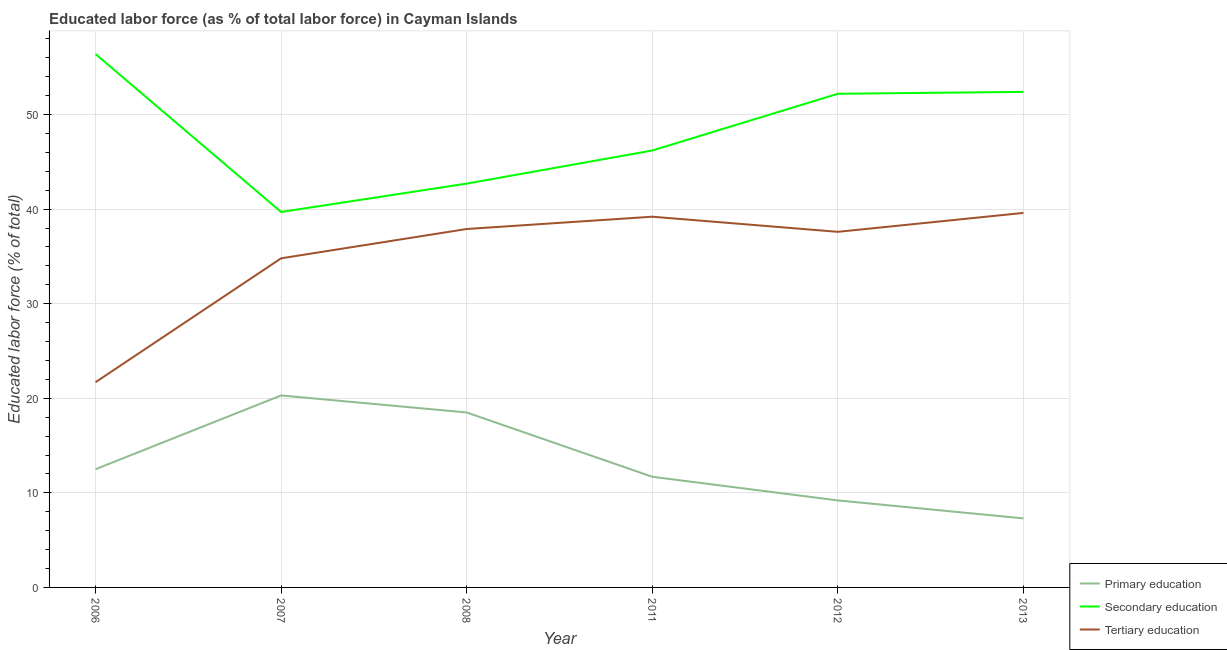Is the number of lines equal to the number of legend labels?
Keep it short and to the point. Yes. What is the percentage of labor force who received primary education in 2006?
Ensure brevity in your answer.  12.5. Across all years, what is the maximum percentage of labor force who received tertiary education?
Offer a very short reply. 39.6. Across all years, what is the minimum percentage of labor force who received tertiary education?
Your answer should be compact. 21.7. In which year was the percentage of labor force who received primary education minimum?
Your response must be concise. 2013. What is the total percentage of labor force who received secondary education in the graph?
Your answer should be very brief. 289.6. What is the difference between the percentage of labor force who received secondary education in 2011 and that in 2013?
Your answer should be compact. -6.2. What is the difference between the percentage of labor force who received tertiary education in 2013 and the percentage of labor force who received secondary education in 2012?
Give a very brief answer. -12.6. What is the average percentage of labor force who received primary education per year?
Offer a very short reply. 13.25. In the year 2012, what is the difference between the percentage of labor force who received tertiary education and percentage of labor force who received secondary education?
Ensure brevity in your answer.  -14.6. In how many years, is the percentage of labor force who received secondary education greater than 10 %?
Give a very brief answer. 6. What is the ratio of the percentage of labor force who received primary education in 2008 to that in 2011?
Make the answer very short. 1.58. Is the difference between the percentage of labor force who received secondary education in 2006 and 2008 greater than the difference between the percentage of labor force who received primary education in 2006 and 2008?
Your answer should be very brief. Yes. What is the difference between the highest and the second highest percentage of labor force who received tertiary education?
Offer a terse response. 0.4. What is the difference between the highest and the lowest percentage of labor force who received tertiary education?
Give a very brief answer. 17.9. In how many years, is the percentage of labor force who received primary education greater than the average percentage of labor force who received primary education taken over all years?
Provide a short and direct response. 2. Is the sum of the percentage of labor force who received primary education in 2011 and 2012 greater than the maximum percentage of labor force who received tertiary education across all years?
Give a very brief answer. No. Does the percentage of labor force who received secondary education monotonically increase over the years?
Give a very brief answer. No. Is the percentage of labor force who received secondary education strictly greater than the percentage of labor force who received primary education over the years?
Provide a succinct answer. Yes. Is the percentage of labor force who received secondary education strictly less than the percentage of labor force who received primary education over the years?
Your answer should be compact. No. How many lines are there?
Make the answer very short. 3. How many years are there in the graph?
Provide a short and direct response. 6. Does the graph contain any zero values?
Provide a short and direct response. No. How many legend labels are there?
Your answer should be very brief. 3. How are the legend labels stacked?
Your answer should be very brief. Vertical. What is the title of the graph?
Ensure brevity in your answer.  Educated labor force (as % of total labor force) in Cayman Islands. What is the label or title of the Y-axis?
Offer a very short reply. Educated labor force (% of total). What is the Educated labor force (% of total) of Secondary education in 2006?
Ensure brevity in your answer.  56.4. What is the Educated labor force (% of total) in Tertiary education in 2006?
Offer a very short reply. 21.7. What is the Educated labor force (% of total) in Primary education in 2007?
Provide a succinct answer. 20.3. What is the Educated labor force (% of total) of Secondary education in 2007?
Your answer should be very brief. 39.7. What is the Educated labor force (% of total) of Tertiary education in 2007?
Ensure brevity in your answer.  34.8. What is the Educated labor force (% of total) of Secondary education in 2008?
Ensure brevity in your answer.  42.7. What is the Educated labor force (% of total) in Tertiary education in 2008?
Give a very brief answer. 37.9. What is the Educated labor force (% of total) in Primary education in 2011?
Make the answer very short. 11.7. What is the Educated labor force (% of total) in Secondary education in 2011?
Offer a very short reply. 46.2. What is the Educated labor force (% of total) in Tertiary education in 2011?
Ensure brevity in your answer.  39.2. What is the Educated labor force (% of total) in Primary education in 2012?
Provide a short and direct response. 9.2. What is the Educated labor force (% of total) in Secondary education in 2012?
Provide a short and direct response. 52.2. What is the Educated labor force (% of total) in Tertiary education in 2012?
Provide a short and direct response. 37.6. What is the Educated labor force (% of total) of Primary education in 2013?
Offer a terse response. 7.3. What is the Educated labor force (% of total) of Secondary education in 2013?
Provide a succinct answer. 52.4. What is the Educated labor force (% of total) of Tertiary education in 2013?
Your answer should be very brief. 39.6. Across all years, what is the maximum Educated labor force (% of total) in Primary education?
Ensure brevity in your answer.  20.3. Across all years, what is the maximum Educated labor force (% of total) of Secondary education?
Ensure brevity in your answer.  56.4. Across all years, what is the maximum Educated labor force (% of total) of Tertiary education?
Provide a short and direct response. 39.6. Across all years, what is the minimum Educated labor force (% of total) in Primary education?
Keep it short and to the point. 7.3. Across all years, what is the minimum Educated labor force (% of total) of Secondary education?
Ensure brevity in your answer.  39.7. Across all years, what is the minimum Educated labor force (% of total) in Tertiary education?
Provide a short and direct response. 21.7. What is the total Educated labor force (% of total) of Primary education in the graph?
Keep it short and to the point. 79.5. What is the total Educated labor force (% of total) in Secondary education in the graph?
Keep it short and to the point. 289.6. What is the total Educated labor force (% of total) of Tertiary education in the graph?
Your answer should be very brief. 210.8. What is the difference between the Educated labor force (% of total) of Tertiary education in 2006 and that in 2008?
Your answer should be very brief. -16.2. What is the difference between the Educated labor force (% of total) in Primary education in 2006 and that in 2011?
Your answer should be very brief. 0.8. What is the difference between the Educated labor force (% of total) in Secondary education in 2006 and that in 2011?
Your answer should be compact. 10.2. What is the difference between the Educated labor force (% of total) in Tertiary education in 2006 and that in 2011?
Ensure brevity in your answer.  -17.5. What is the difference between the Educated labor force (% of total) in Tertiary education in 2006 and that in 2012?
Provide a short and direct response. -15.9. What is the difference between the Educated labor force (% of total) of Tertiary education in 2006 and that in 2013?
Offer a terse response. -17.9. What is the difference between the Educated labor force (% of total) of Primary education in 2007 and that in 2008?
Offer a terse response. 1.8. What is the difference between the Educated labor force (% of total) of Primary education in 2007 and that in 2011?
Keep it short and to the point. 8.6. What is the difference between the Educated labor force (% of total) of Primary education in 2007 and that in 2013?
Ensure brevity in your answer.  13. What is the difference between the Educated labor force (% of total) of Tertiary education in 2007 and that in 2013?
Offer a very short reply. -4.8. What is the difference between the Educated labor force (% of total) in Secondary education in 2008 and that in 2011?
Make the answer very short. -3.5. What is the difference between the Educated labor force (% of total) in Primary education in 2008 and that in 2012?
Your response must be concise. 9.3. What is the difference between the Educated labor force (% of total) of Secondary education in 2008 and that in 2012?
Give a very brief answer. -9.5. What is the difference between the Educated labor force (% of total) in Tertiary education in 2008 and that in 2012?
Offer a terse response. 0.3. What is the difference between the Educated labor force (% of total) of Secondary education in 2008 and that in 2013?
Provide a succinct answer. -9.7. What is the difference between the Educated labor force (% of total) in Secondary education in 2011 and that in 2012?
Offer a very short reply. -6. What is the difference between the Educated labor force (% of total) in Tertiary education in 2011 and that in 2012?
Keep it short and to the point. 1.6. What is the difference between the Educated labor force (% of total) of Secondary education in 2011 and that in 2013?
Your answer should be compact. -6.2. What is the difference between the Educated labor force (% of total) in Primary education in 2006 and the Educated labor force (% of total) in Secondary education in 2007?
Offer a terse response. -27.2. What is the difference between the Educated labor force (% of total) in Primary education in 2006 and the Educated labor force (% of total) in Tertiary education in 2007?
Offer a terse response. -22.3. What is the difference between the Educated labor force (% of total) of Secondary education in 2006 and the Educated labor force (% of total) of Tertiary education in 2007?
Your response must be concise. 21.6. What is the difference between the Educated labor force (% of total) in Primary education in 2006 and the Educated labor force (% of total) in Secondary education in 2008?
Give a very brief answer. -30.2. What is the difference between the Educated labor force (% of total) in Primary education in 2006 and the Educated labor force (% of total) in Tertiary education in 2008?
Your answer should be compact. -25.4. What is the difference between the Educated labor force (% of total) in Secondary education in 2006 and the Educated labor force (% of total) in Tertiary education in 2008?
Your response must be concise. 18.5. What is the difference between the Educated labor force (% of total) in Primary education in 2006 and the Educated labor force (% of total) in Secondary education in 2011?
Ensure brevity in your answer.  -33.7. What is the difference between the Educated labor force (% of total) in Primary education in 2006 and the Educated labor force (% of total) in Tertiary education in 2011?
Keep it short and to the point. -26.7. What is the difference between the Educated labor force (% of total) in Secondary education in 2006 and the Educated labor force (% of total) in Tertiary education in 2011?
Make the answer very short. 17.2. What is the difference between the Educated labor force (% of total) in Primary education in 2006 and the Educated labor force (% of total) in Secondary education in 2012?
Make the answer very short. -39.7. What is the difference between the Educated labor force (% of total) in Primary education in 2006 and the Educated labor force (% of total) in Tertiary education in 2012?
Offer a terse response. -25.1. What is the difference between the Educated labor force (% of total) in Secondary education in 2006 and the Educated labor force (% of total) in Tertiary education in 2012?
Your response must be concise. 18.8. What is the difference between the Educated labor force (% of total) of Primary education in 2006 and the Educated labor force (% of total) of Secondary education in 2013?
Offer a very short reply. -39.9. What is the difference between the Educated labor force (% of total) in Primary education in 2006 and the Educated labor force (% of total) in Tertiary education in 2013?
Make the answer very short. -27.1. What is the difference between the Educated labor force (% of total) in Primary education in 2007 and the Educated labor force (% of total) in Secondary education in 2008?
Offer a very short reply. -22.4. What is the difference between the Educated labor force (% of total) of Primary education in 2007 and the Educated labor force (% of total) of Tertiary education in 2008?
Your response must be concise. -17.6. What is the difference between the Educated labor force (% of total) of Primary education in 2007 and the Educated labor force (% of total) of Secondary education in 2011?
Provide a succinct answer. -25.9. What is the difference between the Educated labor force (% of total) in Primary education in 2007 and the Educated labor force (% of total) in Tertiary education in 2011?
Give a very brief answer. -18.9. What is the difference between the Educated labor force (% of total) in Secondary education in 2007 and the Educated labor force (% of total) in Tertiary education in 2011?
Keep it short and to the point. 0.5. What is the difference between the Educated labor force (% of total) of Primary education in 2007 and the Educated labor force (% of total) of Secondary education in 2012?
Your answer should be compact. -31.9. What is the difference between the Educated labor force (% of total) in Primary education in 2007 and the Educated labor force (% of total) in Tertiary education in 2012?
Your answer should be compact. -17.3. What is the difference between the Educated labor force (% of total) of Secondary education in 2007 and the Educated labor force (% of total) of Tertiary education in 2012?
Offer a very short reply. 2.1. What is the difference between the Educated labor force (% of total) of Primary education in 2007 and the Educated labor force (% of total) of Secondary education in 2013?
Offer a terse response. -32.1. What is the difference between the Educated labor force (% of total) of Primary education in 2007 and the Educated labor force (% of total) of Tertiary education in 2013?
Offer a terse response. -19.3. What is the difference between the Educated labor force (% of total) of Secondary education in 2007 and the Educated labor force (% of total) of Tertiary education in 2013?
Your answer should be very brief. 0.1. What is the difference between the Educated labor force (% of total) in Primary education in 2008 and the Educated labor force (% of total) in Secondary education in 2011?
Give a very brief answer. -27.7. What is the difference between the Educated labor force (% of total) in Primary education in 2008 and the Educated labor force (% of total) in Tertiary education in 2011?
Provide a short and direct response. -20.7. What is the difference between the Educated labor force (% of total) of Secondary education in 2008 and the Educated labor force (% of total) of Tertiary education in 2011?
Your answer should be compact. 3.5. What is the difference between the Educated labor force (% of total) of Primary education in 2008 and the Educated labor force (% of total) of Secondary education in 2012?
Your answer should be very brief. -33.7. What is the difference between the Educated labor force (% of total) in Primary education in 2008 and the Educated labor force (% of total) in Tertiary education in 2012?
Keep it short and to the point. -19.1. What is the difference between the Educated labor force (% of total) of Secondary education in 2008 and the Educated labor force (% of total) of Tertiary education in 2012?
Your answer should be compact. 5.1. What is the difference between the Educated labor force (% of total) in Primary education in 2008 and the Educated labor force (% of total) in Secondary education in 2013?
Offer a very short reply. -33.9. What is the difference between the Educated labor force (% of total) in Primary education in 2008 and the Educated labor force (% of total) in Tertiary education in 2013?
Provide a succinct answer. -21.1. What is the difference between the Educated labor force (% of total) in Primary education in 2011 and the Educated labor force (% of total) in Secondary education in 2012?
Your response must be concise. -40.5. What is the difference between the Educated labor force (% of total) in Primary education in 2011 and the Educated labor force (% of total) in Tertiary education in 2012?
Your answer should be compact. -25.9. What is the difference between the Educated labor force (% of total) of Primary education in 2011 and the Educated labor force (% of total) of Secondary education in 2013?
Your answer should be very brief. -40.7. What is the difference between the Educated labor force (% of total) of Primary education in 2011 and the Educated labor force (% of total) of Tertiary education in 2013?
Provide a succinct answer. -27.9. What is the difference between the Educated labor force (% of total) of Secondary education in 2011 and the Educated labor force (% of total) of Tertiary education in 2013?
Make the answer very short. 6.6. What is the difference between the Educated labor force (% of total) in Primary education in 2012 and the Educated labor force (% of total) in Secondary education in 2013?
Your answer should be compact. -43.2. What is the difference between the Educated labor force (% of total) in Primary education in 2012 and the Educated labor force (% of total) in Tertiary education in 2013?
Ensure brevity in your answer.  -30.4. What is the difference between the Educated labor force (% of total) in Secondary education in 2012 and the Educated labor force (% of total) in Tertiary education in 2013?
Ensure brevity in your answer.  12.6. What is the average Educated labor force (% of total) in Primary education per year?
Offer a terse response. 13.25. What is the average Educated labor force (% of total) of Secondary education per year?
Your response must be concise. 48.27. What is the average Educated labor force (% of total) of Tertiary education per year?
Your answer should be compact. 35.13. In the year 2006, what is the difference between the Educated labor force (% of total) in Primary education and Educated labor force (% of total) in Secondary education?
Provide a succinct answer. -43.9. In the year 2006, what is the difference between the Educated labor force (% of total) of Secondary education and Educated labor force (% of total) of Tertiary education?
Provide a short and direct response. 34.7. In the year 2007, what is the difference between the Educated labor force (% of total) of Primary education and Educated labor force (% of total) of Secondary education?
Provide a short and direct response. -19.4. In the year 2007, what is the difference between the Educated labor force (% of total) of Primary education and Educated labor force (% of total) of Tertiary education?
Your answer should be very brief. -14.5. In the year 2007, what is the difference between the Educated labor force (% of total) in Secondary education and Educated labor force (% of total) in Tertiary education?
Ensure brevity in your answer.  4.9. In the year 2008, what is the difference between the Educated labor force (% of total) of Primary education and Educated labor force (% of total) of Secondary education?
Offer a terse response. -24.2. In the year 2008, what is the difference between the Educated labor force (% of total) in Primary education and Educated labor force (% of total) in Tertiary education?
Your answer should be compact. -19.4. In the year 2008, what is the difference between the Educated labor force (% of total) of Secondary education and Educated labor force (% of total) of Tertiary education?
Give a very brief answer. 4.8. In the year 2011, what is the difference between the Educated labor force (% of total) of Primary education and Educated labor force (% of total) of Secondary education?
Give a very brief answer. -34.5. In the year 2011, what is the difference between the Educated labor force (% of total) in Primary education and Educated labor force (% of total) in Tertiary education?
Your response must be concise. -27.5. In the year 2011, what is the difference between the Educated labor force (% of total) of Secondary education and Educated labor force (% of total) of Tertiary education?
Offer a very short reply. 7. In the year 2012, what is the difference between the Educated labor force (% of total) in Primary education and Educated labor force (% of total) in Secondary education?
Your answer should be very brief. -43. In the year 2012, what is the difference between the Educated labor force (% of total) of Primary education and Educated labor force (% of total) of Tertiary education?
Your answer should be compact. -28.4. In the year 2013, what is the difference between the Educated labor force (% of total) in Primary education and Educated labor force (% of total) in Secondary education?
Provide a succinct answer. -45.1. In the year 2013, what is the difference between the Educated labor force (% of total) of Primary education and Educated labor force (% of total) of Tertiary education?
Your answer should be compact. -32.3. In the year 2013, what is the difference between the Educated labor force (% of total) of Secondary education and Educated labor force (% of total) of Tertiary education?
Make the answer very short. 12.8. What is the ratio of the Educated labor force (% of total) in Primary education in 2006 to that in 2007?
Your answer should be compact. 0.62. What is the ratio of the Educated labor force (% of total) in Secondary education in 2006 to that in 2007?
Make the answer very short. 1.42. What is the ratio of the Educated labor force (% of total) of Tertiary education in 2006 to that in 2007?
Keep it short and to the point. 0.62. What is the ratio of the Educated labor force (% of total) of Primary education in 2006 to that in 2008?
Your answer should be very brief. 0.68. What is the ratio of the Educated labor force (% of total) of Secondary education in 2006 to that in 2008?
Your answer should be compact. 1.32. What is the ratio of the Educated labor force (% of total) in Tertiary education in 2006 to that in 2008?
Your answer should be compact. 0.57. What is the ratio of the Educated labor force (% of total) in Primary education in 2006 to that in 2011?
Provide a succinct answer. 1.07. What is the ratio of the Educated labor force (% of total) of Secondary education in 2006 to that in 2011?
Your response must be concise. 1.22. What is the ratio of the Educated labor force (% of total) in Tertiary education in 2006 to that in 2011?
Provide a succinct answer. 0.55. What is the ratio of the Educated labor force (% of total) in Primary education in 2006 to that in 2012?
Your answer should be compact. 1.36. What is the ratio of the Educated labor force (% of total) of Secondary education in 2006 to that in 2012?
Provide a succinct answer. 1.08. What is the ratio of the Educated labor force (% of total) in Tertiary education in 2006 to that in 2012?
Give a very brief answer. 0.58. What is the ratio of the Educated labor force (% of total) of Primary education in 2006 to that in 2013?
Provide a succinct answer. 1.71. What is the ratio of the Educated labor force (% of total) in Secondary education in 2006 to that in 2013?
Ensure brevity in your answer.  1.08. What is the ratio of the Educated labor force (% of total) in Tertiary education in 2006 to that in 2013?
Give a very brief answer. 0.55. What is the ratio of the Educated labor force (% of total) of Primary education in 2007 to that in 2008?
Provide a short and direct response. 1.1. What is the ratio of the Educated labor force (% of total) of Secondary education in 2007 to that in 2008?
Provide a succinct answer. 0.93. What is the ratio of the Educated labor force (% of total) in Tertiary education in 2007 to that in 2008?
Provide a succinct answer. 0.92. What is the ratio of the Educated labor force (% of total) in Primary education in 2007 to that in 2011?
Ensure brevity in your answer.  1.74. What is the ratio of the Educated labor force (% of total) in Secondary education in 2007 to that in 2011?
Your answer should be very brief. 0.86. What is the ratio of the Educated labor force (% of total) of Tertiary education in 2007 to that in 2011?
Your answer should be very brief. 0.89. What is the ratio of the Educated labor force (% of total) in Primary education in 2007 to that in 2012?
Make the answer very short. 2.21. What is the ratio of the Educated labor force (% of total) of Secondary education in 2007 to that in 2012?
Ensure brevity in your answer.  0.76. What is the ratio of the Educated labor force (% of total) of Tertiary education in 2007 to that in 2012?
Offer a terse response. 0.93. What is the ratio of the Educated labor force (% of total) in Primary education in 2007 to that in 2013?
Your response must be concise. 2.78. What is the ratio of the Educated labor force (% of total) of Secondary education in 2007 to that in 2013?
Your answer should be very brief. 0.76. What is the ratio of the Educated labor force (% of total) in Tertiary education in 2007 to that in 2013?
Your response must be concise. 0.88. What is the ratio of the Educated labor force (% of total) of Primary education in 2008 to that in 2011?
Your answer should be compact. 1.58. What is the ratio of the Educated labor force (% of total) of Secondary education in 2008 to that in 2011?
Your response must be concise. 0.92. What is the ratio of the Educated labor force (% of total) of Tertiary education in 2008 to that in 2011?
Your answer should be compact. 0.97. What is the ratio of the Educated labor force (% of total) of Primary education in 2008 to that in 2012?
Give a very brief answer. 2.01. What is the ratio of the Educated labor force (% of total) of Secondary education in 2008 to that in 2012?
Your answer should be very brief. 0.82. What is the ratio of the Educated labor force (% of total) of Tertiary education in 2008 to that in 2012?
Your answer should be very brief. 1.01. What is the ratio of the Educated labor force (% of total) in Primary education in 2008 to that in 2013?
Ensure brevity in your answer.  2.53. What is the ratio of the Educated labor force (% of total) in Secondary education in 2008 to that in 2013?
Keep it short and to the point. 0.81. What is the ratio of the Educated labor force (% of total) in Tertiary education in 2008 to that in 2013?
Ensure brevity in your answer.  0.96. What is the ratio of the Educated labor force (% of total) of Primary education in 2011 to that in 2012?
Make the answer very short. 1.27. What is the ratio of the Educated labor force (% of total) in Secondary education in 2011 to that in 2012?
Your answer should be compact. 0.89. What is the ratio of the Educated labor force (% of total) of Tertiary education in 2011 to that in 2012?
Provide a succinct answer. 1.04. What is the ratio of the Educated labor force (% of total) in Primary education in 2011 to that in 2013?
Make the answer very short. 1.6. What is the ratio of the Educated labor force (% of total) of Secondary education in 2011 to that in 2013?
Give a very brief answer. 0.88. What is the ratio of the Educated labor force (% of total) of Tertiary education in 2011 to that in 2013?
Your answer should be very brief. 0.99. What is the ratio of the Educated labor force (% of total) in Primary education in 2012 to that in 2013?
Make the answer very short. 1.26. What is the ratio of the Educated labor force (% of total) of Tertiary education in 2012 to that in 2013?
Give a very brief answer. 0.95. What is the difference between the highest and the second highest Educated labor force (% of total) in Primary education?
Provide a succinct answer. 1.8. What is the difference between the highest and the second highest Educated labor force (% of total) of Tertiary education?
Provide a short and direct response. 0.4. What is the difference between the highest and the lowest Educated labor force (% of total) of Tertiary education?
Your answer should be compact. 17.9. 